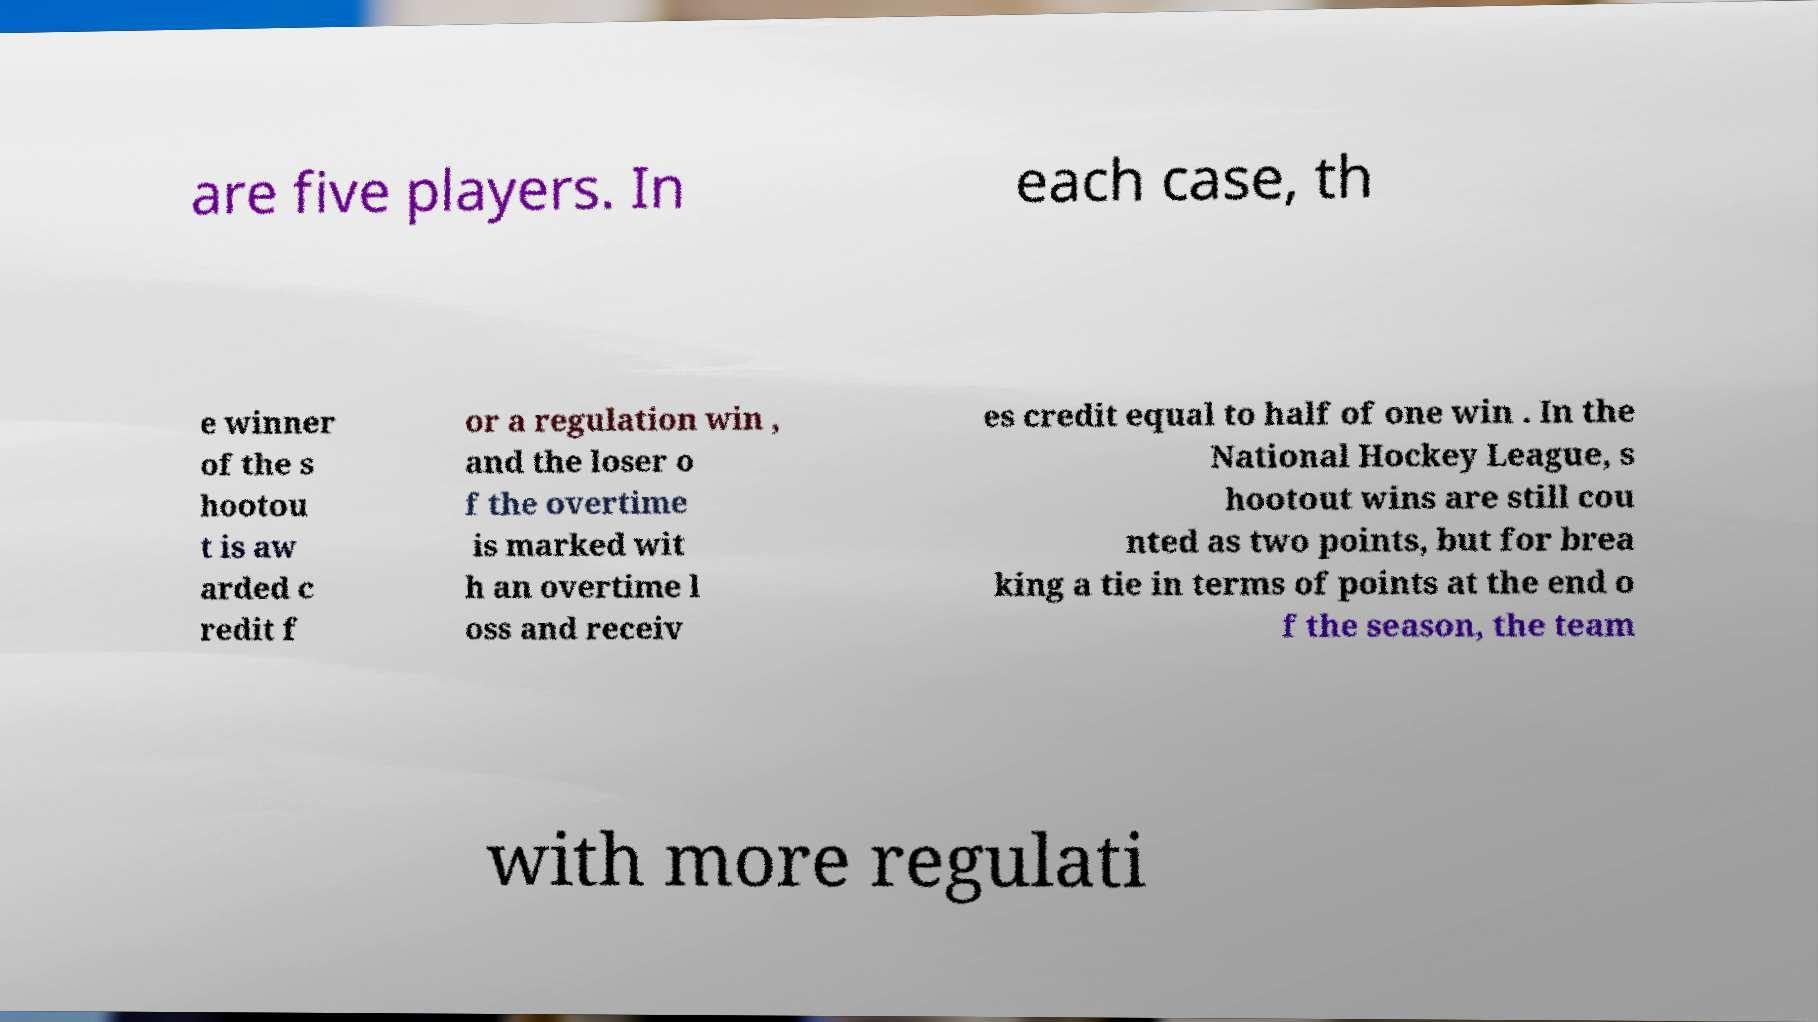For documentation purposes, I need the text within this image transcribed. Could you provide that? are five players. In each case, th e winner of the s hootou t is aw arded c redit f or a regulation win , and the loser o f the overtime is marked wit h an overtime l oss and receiv es credit equal to half of one win . In the National Hockey League, s hootout wins are still cou nted as two points, but for brea king a tie in terms of points at the end o f the season, the team with more regulati 